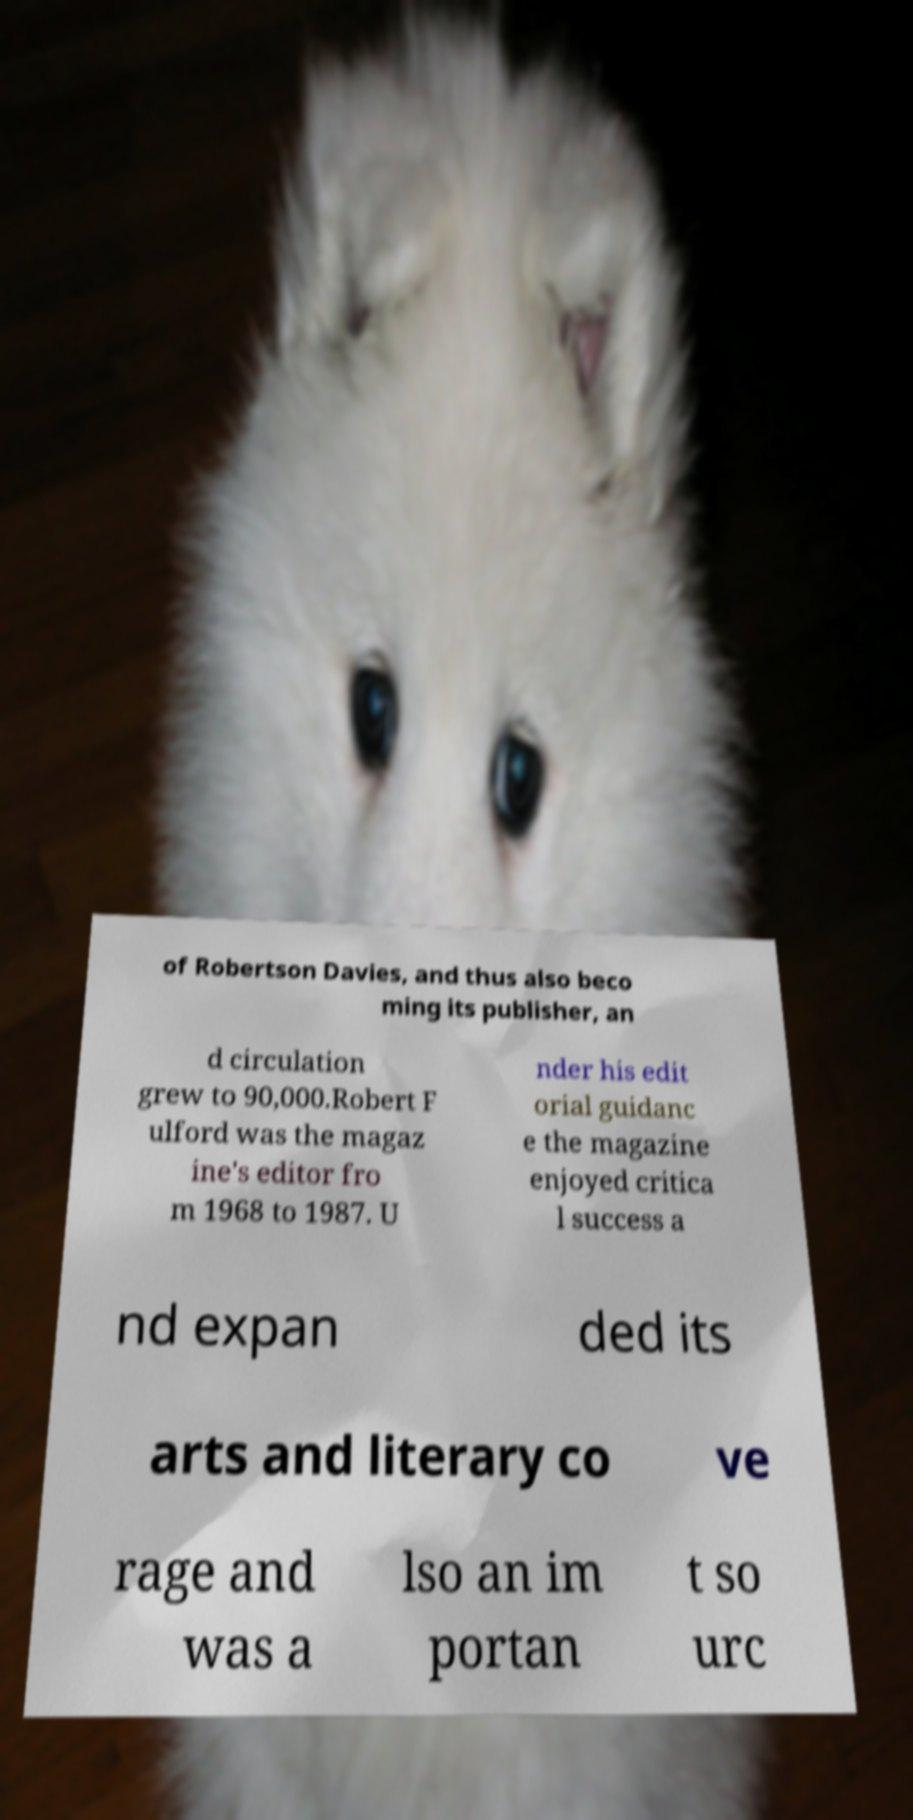Can you accurately transcribe the text from the provided image for me? of Robertson Davies, and thus also beco ming its publisher, an d circulation grew to 90,000.Robert F ulford was the magaz ine's editor fro m 1968 to 1987. U nder his edit orial guidanc e the magazine enjoyed critica l success a nd expan ded its arts and literary co ve rage and was a lso an im portan t so urc 